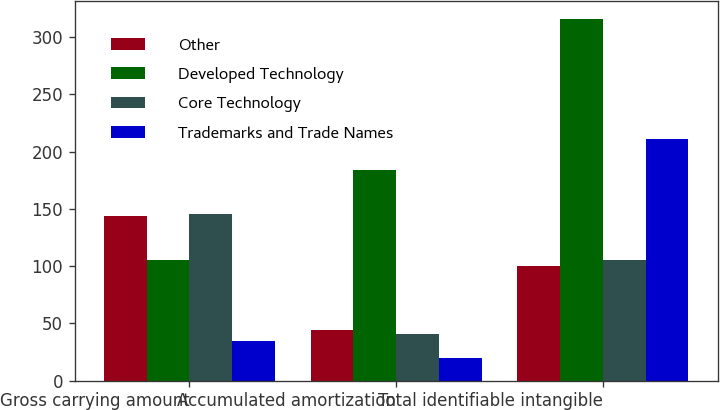<chart> <loc_0><loc_0><loc_500><loc_500><stacked_bar_chart><ecel><fcel>Gross carrying amount<fcel>Accumulated amortization<fcel>Total identifiable intangible<nl><fcel>Other<fcel>144.1<fcel>44<fcel>100.1<nl><fcel>Developed Technology<fcel>104.9<fcel>183.5<fcel>315.6<nl><fcel>Core Technology<fcel>145.2<fcel>40.3<fcel>104.9<nl><fcel>Trademarks and Trade Names<fcel>34.7<fcel>20<fcel>211.2<nl></chart> 